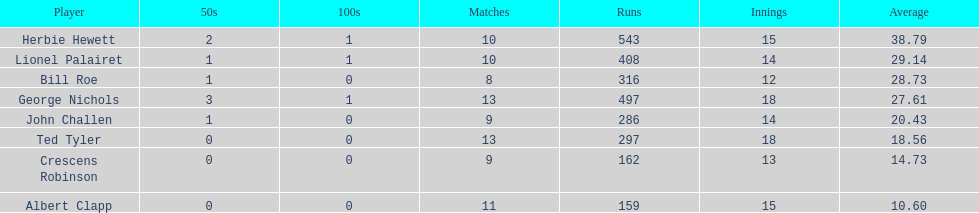Which player had the least amount of runs? Albert Clapp. 